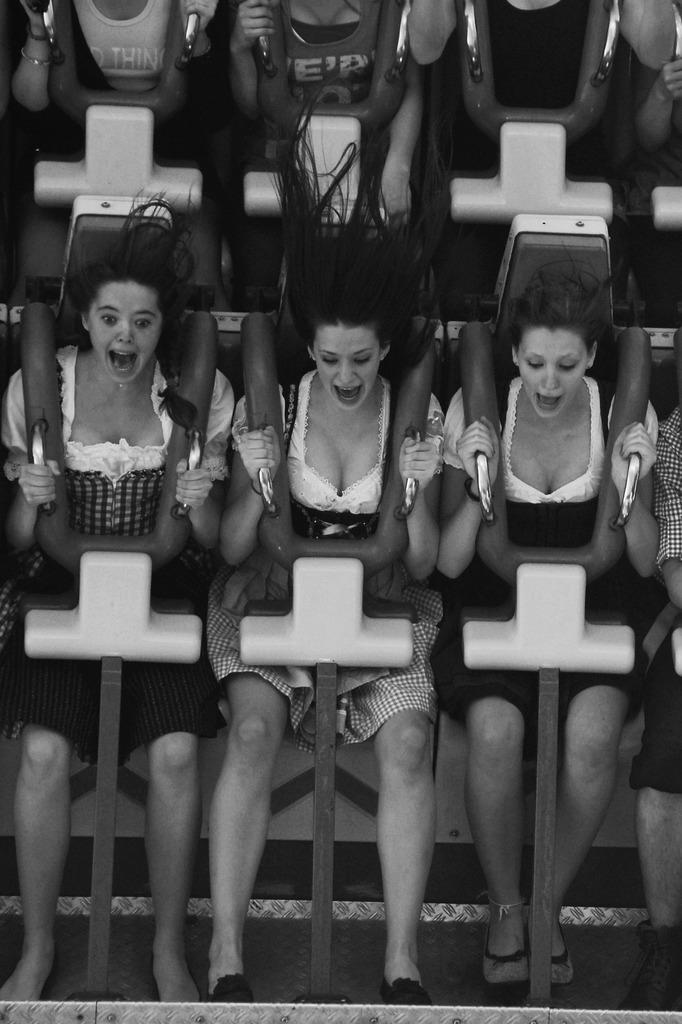What is the color scheme of the image? The image is black and white. What can be seen in the image besides the color scheme? There are people in the image. What are the people doing in the image? The people are sitting in a roller coaster. How are the people reacting to the roller coaster? The people are shouting. What type of organization is responsible for the ocean in the image? There is no ocean present in the image, so it is not possible to determine which organization might be responsible for it. 